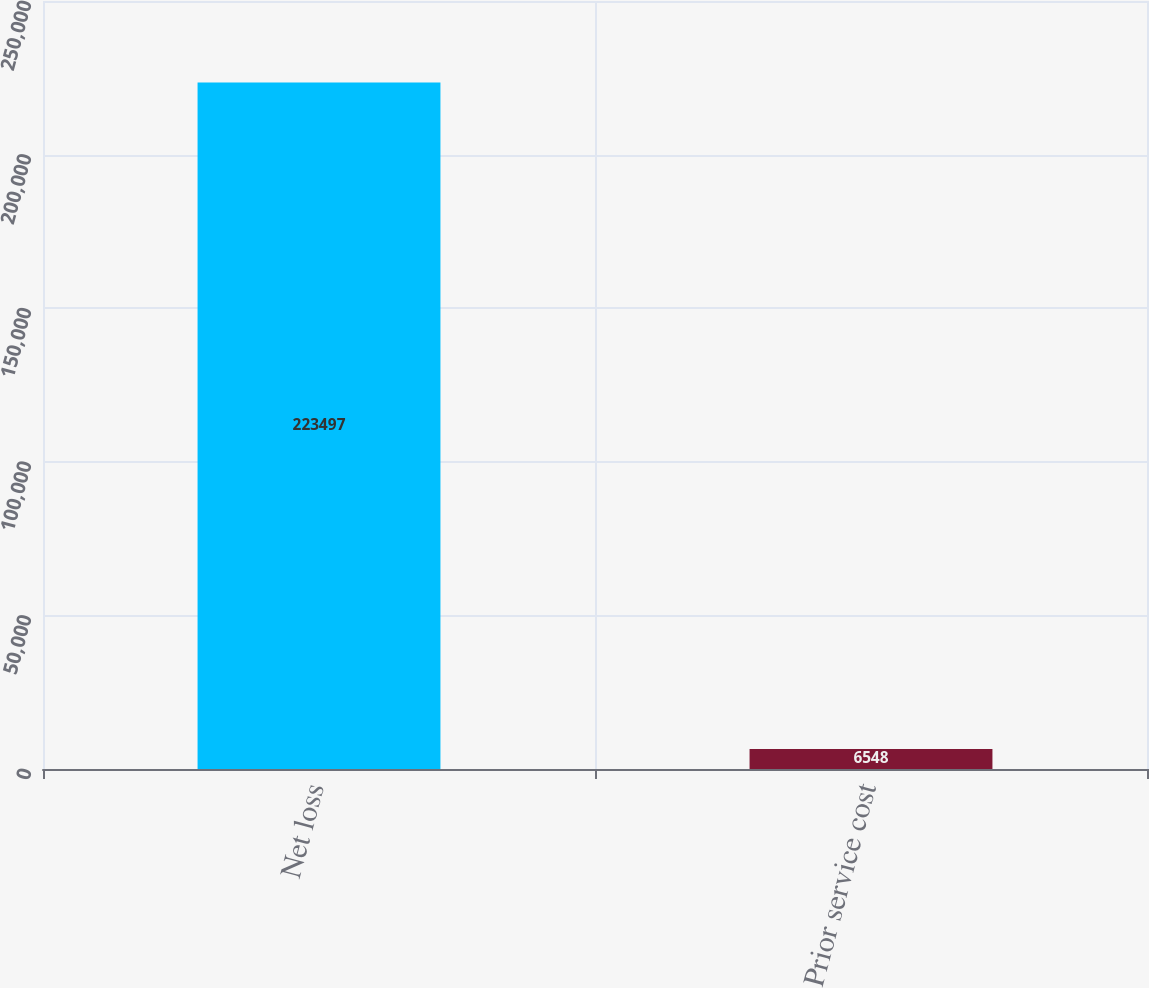<chart> <loc_0><loc_0><loc_500><loc_500><bar_chart><fcel>Net loss<fcel>Prior service cost<nl><fcel>223497<fcel>6548<nl></chart> 